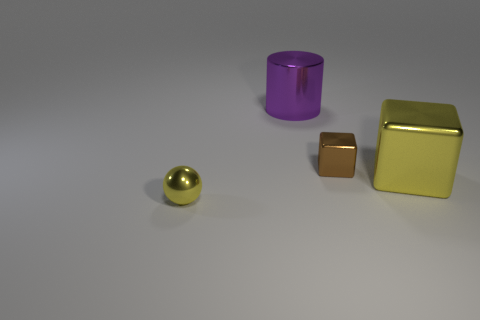The big metallic thing that is the same color as the metallic ball is what shape?
Ensure brevity in your answer.  Cube. Is the color of the object right of the tiny shiny cube the same as the small thing on the left side of the purple metallic thing?
Ensure brevity in your answer.  Yes. What is the color of the cylinder that is the same size as the yellow cube?
Keep it short and to the point. Purple. Is there a large metallic thing that has the same color as the large shiny cube?
Your answer should be very brief. No. Does the yellow ball in front of the brown object have the same size as the small metal cube?
Offer a very short reply. Yes. Is the number of big objects that are in front of the purple thing the same as the number of big purple shiny things?
Your response must be concise. Yes. How many things are either metallic objects that are behind the tiny metallic ball or small brown shiny things?
Your answer should be compact. 3. There is a thing that is left of the small metal block and behind the yellow metallic block; what shape is it?
Give a very brief answer. Cylinder. What number of objects are tiny metallic objects to the left of the purple cylinder or tiny things left of the purple cylinder?
Ensure brevity in your answer.  1. How many other objects are there of the same size as the shiny cylinder?
Your response must be concise. 1. 